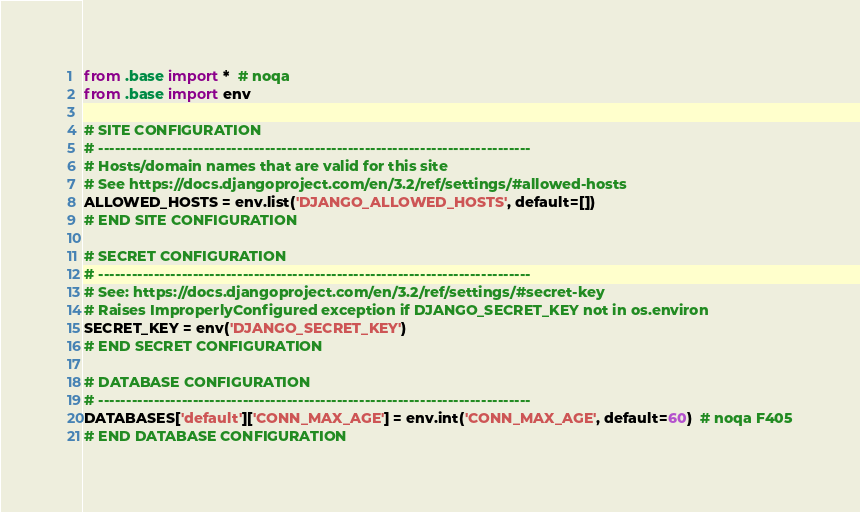<code> <loc_0><loc_0><loc_500><loc_500><_Python_>from .base import *  # noqa
from .base import env 

# SITE CONFIGURATION
# ------------------------------------------------------------------------------
# Hosts/domain names that are valid for this site
# See https://docs.djangoproject.com/en/3.2/ref/settings/#allowed-hosts
ALLOWED_HOSTS = env.list('DJANGO_ALLOWED_HOSTS', default=[])
# END SITE CONFIGURATION

# SECRET CONFIGURATION
# ------------------------------------------------------------------------------
# See: https://docs.djangoproject.com/en/3.2/ref/settings/#secret-key
# Raises ImproperlyConfigured exception if DJANGO_SECRET_KEY not in os.environ
SECRET_KEY = env('DJANGO_SECRET_KEY')
# END SECRET CONFIGURATION

# DATABASE CONFIGURATION
# ------------------------------------------------------------------------------
DATABASES['default']['CONN_MAX_AGE'] = env.int('CONN_MAX_AGE', default=60)  # noqa F405
# END DATABASE CONFIGURATION
</code> 